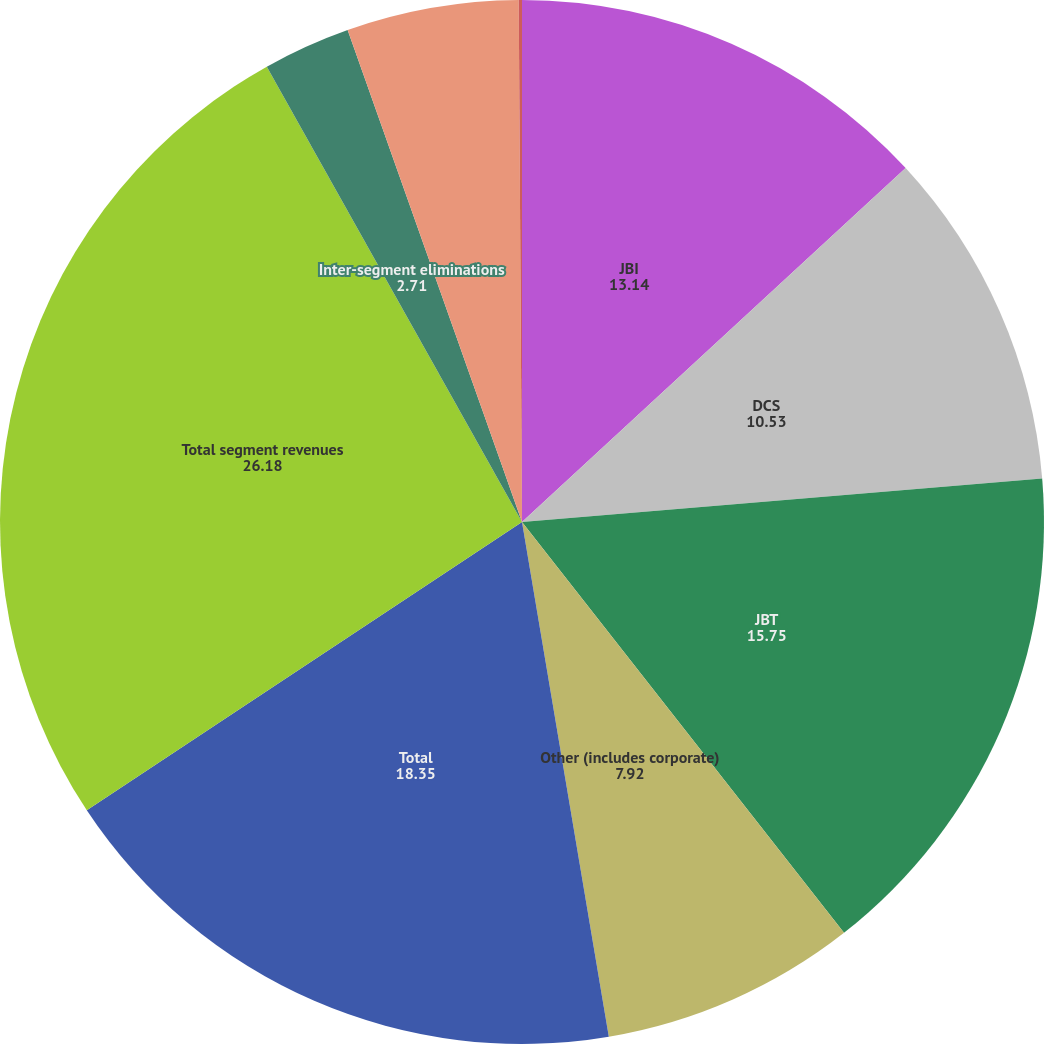Convert chart to OTSL. <chart><loc_0><loc_0><loc_500><loc_500><pie_chart><fcel>JBI<fcel>DCS<fcel>JBT<fcel>Other (includes corporate)<fcel>Total<fcel>Total segment revenues<fcel>Inter-segment eliminations<fcel>JBI (2)<fcel>Other<nl><fcel>13.14%<fcel>10.53%<fcel>15.75%<fcel>7.92%<fcel>18.35%<fcel>26.18%<fcel>2.71%<fcel>5.32%<fcel>0.1%<nl></chart> 